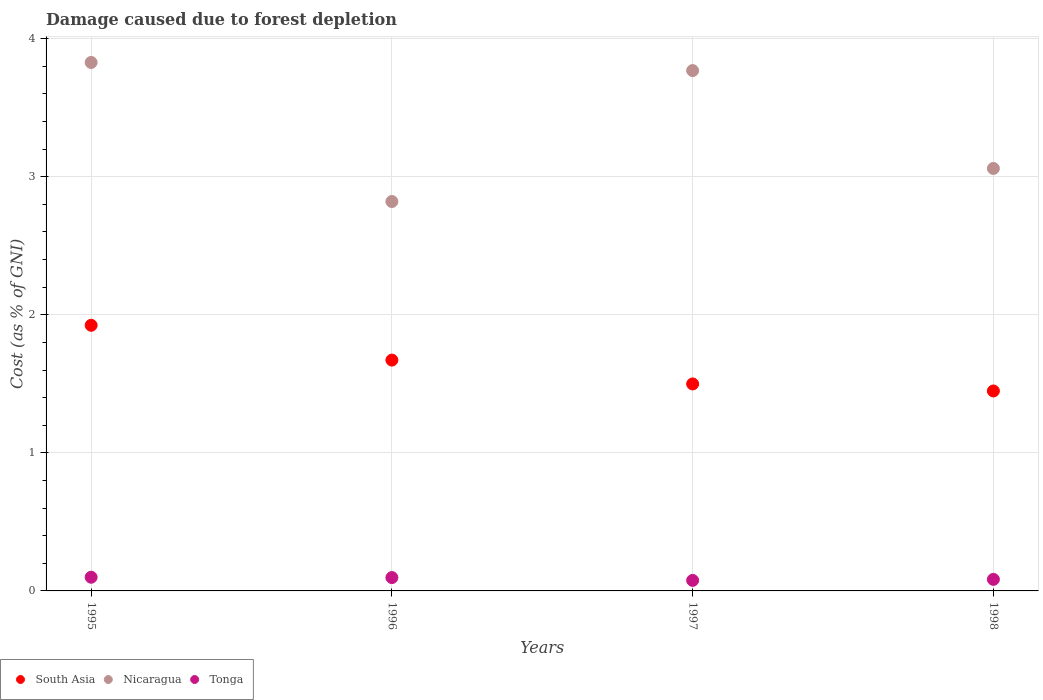How many different coloured dotlines are there?
Your response must be concise. 3. What is the cost of damage caused due to forest depletion in Nicaragua in 1998?
Provide a short and direct response. 3.06. Across all years, what is the maximum cost of damage caused due to forest depletion in Tonga?
Give a very brief answer. 0.1. Across all years, what is the minimum cost of damage caused due to forest depletion in Nicaragua?
Ensure brevity in your answer.  2.82. In which year was the cost of damage caused due to forest depletion in South Asia maximum?
Ensure brevity in your answer.  1995. In which year was the cost of damage caused due to forest depletion in South Asia minimum?
Make the answer very short. 1998. What is the total cost of damage caused due to forest depletion in South Asia in the graph?
Offer a very short reply. 6.54. What is the difference between the cost of damage caused due to forest depletion in Tonga in 1995 and that in 1998?
Offer a very short reply. 0.02. What is the difference between the cost of damage caused due to forest depletion in South Asia in 1997 and the cost of damage caused due to forest depletion in Nicaragua in 1995?
Your answer should be very brief. -2.33. What is the average cost of damage caused due to forest depletion in South Asia per year?
Ensure brevity in your answer.  1.64. In the year 1998, what is the difference between the cost of damage caused due to forest depletion in Nicaragua and cost of damage caused due to forest depletion in South Asia?
Give a very brief answer. 1.61. In how many years, is the cost of damage caused due to forest depletion in Tonga greater than 2.6 %?
Your response must be concise. 0. What is the ratio of the cost of damage caused due to forest depletion in South Asia in 1996 to that in 1997?
Make the answer very short. 1.12. Is the cost of damage caused due to forest depletion in South Asia in 1996 less than that in 1998?
Your answer should be very brief. No. Is the difference between the cost of damage caused due to forest depletion in Nicaragua in 1995 and 1997 greater than the difference between the cost of damage caused due to forest depletion in South Asia in 1995 and 1997?
Offer a terse response. No. What is the difference between the highest and the second highest cost of damage caused due to forest depletion in Tonga?
Make the answer very short. 0. What is the difference between the highest and the lowest cost of damage caused due to forest depletion in South Asia?
Provide a short and direct response. 0.48. Does the cost of damage caused due to forest depletion in Tonga monotonically increase over the years?
Provide a short and direct response. No. Is the cost of damage caused due to forest depletion in Tonga strictly less than the cost of damage caused due to forest depletion in Nicaragua over the years?
Your response must be concise. Yes. How many dotlines are there?
Your answer should be very brief. 3. Are the values on the major ticks of Y-axis written in scientific E-notation?
Your answer should be very brief. No. How many legend labels are there?
Your response must be concise. 3. What is the title of the graph?
Ensure brevity in your answer.  Damage caused due to forest depletion. Does "Curacao" appear as one of the legend labels in the graph?
Offer a terse response. No. What is the label or title of the Y-axis?
Keep it short and to the point. Cost (as % of GNI). What is the Cost (as % of GNI) in South Asia in 1995?
Provide a succinct answer. 1.92. What is the Cost (as % of GNI) of Nicaragua in 1995?
Give a very brief answer. 3.83. What is the Cost (as % of GNI) in Tonga in 1995?
Your answer should be compact. 0.1. What is the Cost (as % of GNI) of South Asia in 1996?
Provide a short and direct response. 1.67. What is the Cost (as % of GNI) of Nicaragua in 1996?
Ensure brevity in your answer.  2.82. What is the Cost (as % of GNI) of Tonga in 1996?
Your answer should be compact. 0.1. What is the Cost (as % of GNI) in South Asia in 1997?
Make the answer very short. 1.5. What is the Cost (as % of GNI) of Nicaragua in 1997?
Give a very brief answer. 3.77. What is the Cost (as % of GNI) of Tonga in 1997?
Make the answer very short. 0.08. What is the Cost (as % of GNI) of South Asia in 1998?
Keep it short and to the point. 1.45. What is the Cost (as % of GNI) of Nicaragua in 1998?
Provide a short and direct response. 3.06. What is the Cost (as % of GNI) of Tonga in 1998?
Keep it short and to the point. 0.08. Across all years, what is the maximum Cost (as % of GNI) of South Asia?
Your answer should be very brief. 1.92. Across all years, what is the maximum Cost (as % of GNI) of Nicaragua?
Offer a very short reply. 3.83. Across all years, what is the maximum Cost (as % of GNI) in Tonga?
Provide a short and direct response. 0.1. Across all years, what is the minimum Cost (as % of GNI) in South Asia?
Keep it short and to the point. 1.45. Across all years, what is the minimum Cost (as % of GNI) of Nicaragua?
Give a very brief answer. 2.82. Across all years, what is the minimum Cost (as % of GNI) of Tonga?
Give a very brief answer. 0.08. What is the total Cost (as % of GNI) of South Asia in the graph?
Provide a short and direct response. 6.54. What is the total Cost (as % of GNI) in Nicaragua in the graph?
Your answer should be very brief. 13.48. What is the total Cost (as % of GNI) of Tonga in the graph?
Your answer should be very brief. 0.36. What is the difference between the Cost (as % of GNI) in South Asia in 1995 and that in 1996?
Make the answer very short. 0.25. What is the difference between the Cost (as % of GNI) of Nicaragua in 1995 and that in 1996?
Ensure brevity in your answer.  1.01. What is the difference between the Cost (as % of GNI) of Tonga in 1995 and that in 1996?
Offer a very short reply. 0. What is the difference between the Cost (as % of GNI) of South Asia in 1995 and that in 1997?
Provide a succinct answer. 0.42. What is the difference between the Cost (as % of GNI) of Nicaragua in 1995 and that in 1997?
Give a very brief answer. 0.06. What is the difference between the Cost (as % of GNI) of Tonga in 1995 and that in 1997?
Provide a short and direct response. 0.02. What is the difference between the Cost (as % of GNI) in South Asia in 1995 and that in 1998?
Give a very brief answer. 0.48. What is the difference between the Cost (as % of GNI) in Nicaragua in 1995 and that in 1998?
Give a very brief answer. 0.77. What is the difference between the Cost (as % of GNI) of Tonga in 1995 and that in 1998?
Your answer should be compact. 0.02. What is the difference between the Cost (as % of GNI) in South Asia in 1996 and that in 1997?
Offer a terse response. 0.17. What is the difference between the Cost (as % of GNI) in Nicaragua in 1996 and that in 1997?
Offer a very short reply. -0.95. What is the difference between the Cost (as % of GNI) of Tonga in 1996 and that in 1997?
Keep it short and to the point. 0.02. What is the difference between the Cost (as % of GNI) of South Asia in 1996 and that in 1998?
Your answer should be compact. 0.22. What is the difference between the Cost (as % of GNI) in Nicaragua in 1996 and that in 1998?
Your answer should be compact. -0.24. What is the difference between the Cost (as % of GNI) in Tonga in 1996 and that in 1998?
Your answer should be very brief. 0.01. What is the difference between the Cost (as % of GNI) of South Asia in 1997 and that in 1998?
Provide a short and direct response. 0.05. What is the difference between the Cost (as % of GNI) in Nicaragua in 1997 and that in 1998?
Your response must be concise. 0.71. What is the difference between the Cost (as % of GNI) of Tonga in 1997 and that in 1998?
Ensure brevity in your answer.  -0.01. What is the difference between the Cost (as % of GNI) in South Asia in 1995 and the Cost (as % of GNI) in Nicaragua in 1996?
Provide a short and direct response. -0.9. What is the difference between the Cost (as % of GNI) of South Asia in 1995 and the Cost (as % of GNI) of Tonga in 1996?
Give a very brief answer. 1.83. What is the difference between the Cost (as % of GNI) in Nicaragua in 1995 and the Cost (as % of GNI) in Tonga in 1996?
Your answer should be very brief. 3.73. What is the difference between the Cost (as % of GNI) in South Asia in 1995 and the Cost (as % of GNI) in Nicaragua in 1997?
Your answer should be very brief. -1.85. What is the difference between the Cost (as % of GNI) in South Asia in 1995 and the Cost (as % of GNI) in Tonga in 1997?
Ensure brevity in your answer.  1.85. What is the difference between the Cost (as % of GNI) of Nicaragua in 1995 and the Cost (as % of GNI) of Tonga in 1997?
Offer a very short reply. 3.75. What is the difference between the Cost (as % of GNI) of South Asia in 1995 and the Cost (as % of GNI) of Nicaragua in 1998?
Keep it short and to the point. -1.14. What is the difference between the Cost (as % of GNI) in South Asia in 1995 and the Cost (as % of GNI) in Tonga in 1998?
Make the answer very short. 1.84. What is the difference between the Cost (as % of GNI) of Nicaragua in 1995 and the Cost (as % of GNI) of Tonga in 1998?
Provide a succinct answer. 3.74. What is the difference between the Cost (as % of GNI) in South Asia in 1996 and the Cost (as % of GNI) in Nicaragua in 1997?
Keep it short and to the point. -2.1. What is the difference between the Cost (as % of GNI) in South Asia in 1996 and the Cost (as % of GNI) in Tonga in 1997?
Provide a succinct answer. 1.6. What is the difference between the Cost (as % of GNI) in Nicaragua in 1996 and the Cost (as % of GNI) in Tonga in 1997?
Offer a terse response. 2.74. What is the difference between the Cost (as % of GNI) in South Asia in 1996 and the Cost (as % of GNI) in Nicaragua in 1998?
Make the answer very short. -1.39. What is the difference between the Cost (as % of GNI) in South Asia in 1996 and the Cost (as % of GNI) in Tonga in 1998?
Your answer should be very brief. 1.59. What is the difference between the Cost (as % of GNI) of Nicaragua in 1996 and the Cost (as % of GNI) of Tonga in 1998?
Offer a terse response. 2.74. What is the difference between the Cost (as % of GNI) of South Asia in 1997 and the Cost (as % of GNI) of Nicaragua in 1998?
Give a very brief answer. -1.56. What is the difference between the Cost (as % of GNI) of South Asia in 1997 and the Cost (as % of GNI) of Tonga in 1998?
Provide a succinct answer. 1.42. What is the difference between the Cost (as % of GNI) in Nicaragua in 1997 and the Cost (as % of GNI) in Tonga in 1998?
Give a very brief answer. 3.69. What is the average Cost (as % of GNI) of South Asia per year?
Your answer should be compact. 1.64. What is the average Cost (as % of GNI) of Nicaragua per year?
Provide a short and direct response. 3.37. What is the average Cost (as % of GNI) of Tonga per year?
Provide a short and direct response. 0.09. In the year 1995, what is the difference between the Cost (as % of GNI) in South Asia and Cost (as % of GNI) in Nicaragua?
Make the answer very short. -1.9. In the year 1995, what is the difference between the Cost (as % of GNI) of South Asia and Cost (as % of GNI) of Tonga?
Provide a short and direct response. 1.83. In the year 1995, what is the difference between the Cost (as % of GNI) in Nicaragua and Cost (as % of GNI) in Tonga?
Your answer should be very brief. 3.73. In the year 1996, what is the difference between the Cost (as % of GNI) of South Asia and Cost (as % of GNI) of Nicaragua?
Provide a short and direct response. -1.15. In the year 1996, what is the difference between the Cost (as % of GNI) in South Asia and Cost (as % of GNI) in Tonga?
Keep it short and to the point. 1.58. In the year 1996, what is the difference between the Cost (as % of GNI) in Nicaragua and Cost (as % of GNI) in Tonga?
Your response must be concise. 2.72. In the year 1997, what is the difference between the Cost (as % of GNI) of South Asia and Cost (as % of GNI) of Nicaragua?
Provide a short and direct response. -2.27. In the year 1997, what is the difference between the Cost (as % of GNI) of South Asia and Cost (as % of GNI) of Tonga?
Offer a very short reply. 1.42. In the year 1997, what is the difference between the Cost (as % of GNI) of Nicaragua and Cost (as % of GNI) of Tonga?
Provide a succinct answer. 3.69. In the year 1998, what is the difference between the Cost (as % of GNI) in South Asia and Cost (as % of GNI) in Nicaragua?
Offer a terse response. -1.61. In the year 1998, what is the difference between the Cost (as % of GNI) in South Asia and Cost (as % of GNI) in Tonga?
Provide a succinct answer. 1.36. In the year 1998, what is the difference between the Cost (as % of GNI) in Nicaragua and Cost (as % of GNI) in Tonga?
Your answer should be very brief. 2.98. What is the ratio of the Cost (as % of GNI) of South Asia in 1995 to that in 1996?
Provide a short and direct response. 1.15. What is the ratio of the Cost (as % of GNI) of Nicaragua in 1995 to that in 1996?
Provide a short and direct response. 1.36. What is the ratio of the Cost (as % of GNI) in Tonga in 1995 to that in 1996?
Keep it short and to the point. 1.02. What is the ratio of the Cost (as % of GNI) of South Asia in 1995 to that in 1997?
Offer a very short reply. 1.28. What is the ratio of the Cost (as % of GNI) of Nicaragua in 1995 to that in 1997?
Your response must be concise. 1.02. What is the ratio of the Cost (as % of GNI) of Tonga in 1995 to that in 1997?
Keep it short and to the point. 1.3. What is the ratio of the Cost (as % of GNI) of South Asia in 1995 to that in 1998?
Ensure brevity in your answer.  1.33. What is the ratio of the Cost (as % of GNI) of Nicaragua in 1995 to that in 1998?
Make the answer very short. 1.25. What is the ratio of the Cost (as % of GNI) in Tonga in 1995 to that in 1998?
Keep it short and to the point. 1.18. What is the ratio of the Cost (as % of GNI) in South Asia in 1996 to that in 1997?
Offer a very short reply. 1.12. What is the ratio of the Cost (as % of GNI) in Nicaragua in 1996 to that in 1997?
Give a very brief answer. 0.75. What is the ratio of the Cost (as % of GNI) in Tonga in 1996 to that in 1997?
Give a very brief answer. 1.27. What is the ratio of the Cost (as % of GNI) in South Asia in 1996 to that in 1998?
Provide a succinct answer. 1.15. What is the ratio of the Cost (as % of GNI) in Nicaragua in 1996 to that in 1998?
Offer a terse response. 0.92. What is the ratio of the Cost (as % of GNI) in Tonga in 1996 to that in 1998?
Offer a very short reply. 1.16. What is the ratio of the Cost (as % of GNI) in South Asia in 1997 to that in 1998?
Provide a short and direct response. 1.04. What is the ratio of the Cost (as % of GNI) of Nicaragua in 1997 to that in 1998?
Offer a terse response. 1.23. What is the ratio of the Cost (as % of GNI) of Tonga in 1997 to that in 1998?
Your response must be concise. 0.91. What is the difference between the highest and the second highest Cost (as % of GNI) in South Asia?
Provide a succinct answer. 0.25. What is the difference between the highest and the second highest Cost (as % of GNI) in Nicaragua?
Keep it short and to the point. 0.06. What is the difference between the highest and the second highest Cost (as % of GNI) in Tonga?
Ensure brevity in your answer.  0. What is the difference between the highest and the lowest Cost (as % of GNI) in South Asia?
Ensure brevity in your answer.  0.48. What is the difference between the highest and the lowest Cost (as % of GNI) in Nicaragua?
Provide a short and direct response. 1.01. What is the difference between the highest and the lowest Cost (as % of GNI) of Tonga?
Provide a short and direct response. 0.02. 